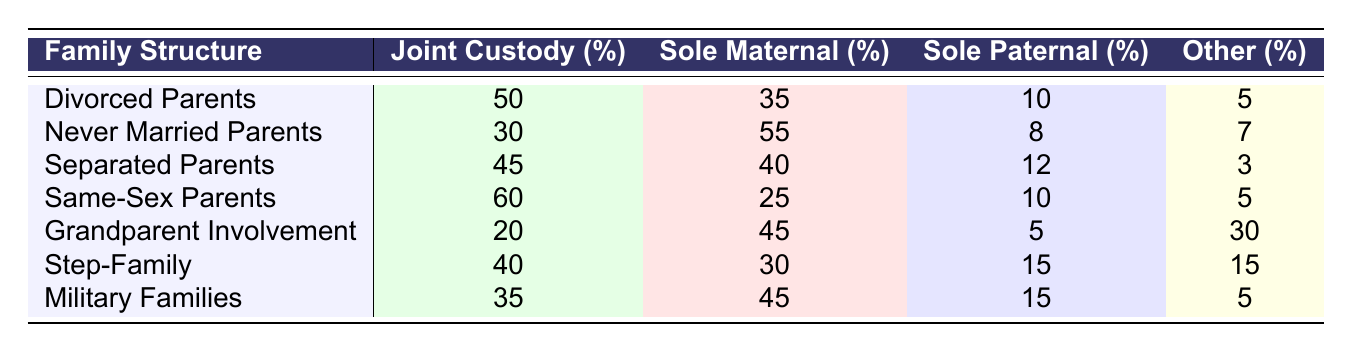What percentage of Never Married Parents have Sole Maternal Custody? The table shows that for Never Married Parents, Sole Maternal Custody is 55%.
Answer: 55% Which family structure has the highest percentage of Joint Custody? According to the table, Same-Sex Parents have the highest percentage of Joint Custody at 60%.
Answer: 60% What is the percentage difference in Joint Custody between Divorced Parents and Separated Parents? Divorced Parents have Joint Custody at 50%, while Separated Parents have it at 45%. The difference is 50% - 45% = 5%.
Answer: 5% Are Grandparent Involvement families more likely to have Sole Maternal Custody than Step-Family arrangements? Grandparent Involvement has 45% for Sole Maternal Custody, while Step-Family arrangements have 30%. Thus, it is true that Grandparent Involvement families have more.
Answer: Yes What is the total percentage of Sole Paternal Custody across all family structures? The total for Sole Paternal Custody is calculated by adding each value: 10 + 8 + 12 + 10 + 5 + 15 + 15 = 75%.
Answer: 75% Which family structure has the lowest percentage of Other Arrangements? The table indicates that Divorced Parents have the lowest percentage of Other Arrangements at 5%.
Answer: 5% If we combine the Sole Maternal and Sole Paternal Custody percentages for Military Families, what is the total? For Military Families, Sole Maternal Custody is 45% and Sole Paternal Custody is 15%. Therefore, the total is 45% + 15% = 60%.
Answer: 60% Is it true that the percentage of Sole Paternal Custody is higher in Separated Parents than in Never Married Parents? Separated Parents have 12% for Sole Paternal Custody, while Never Married Parents have 8%. Thus, the statement is true.
Answer: Yes What is the average percentage of Joint Custody among all family structures? To find the average, sum the Joint Custody percentages: 50 + 30 + 45 + 60 + 20 + 40 + 35 = 280. Then divide by 7 (the number of family structures): 280/7 = 40%.
Answer: 40% Which family structure has the highest combined percentage of Sole Maternal and Other Arrangements? For Never Married Parents, Sole Maternal Custody is 55% and Other Arrangements is 7%, totaling 62%. This is the highest when compared to others.
Answer: Never Married Parents 